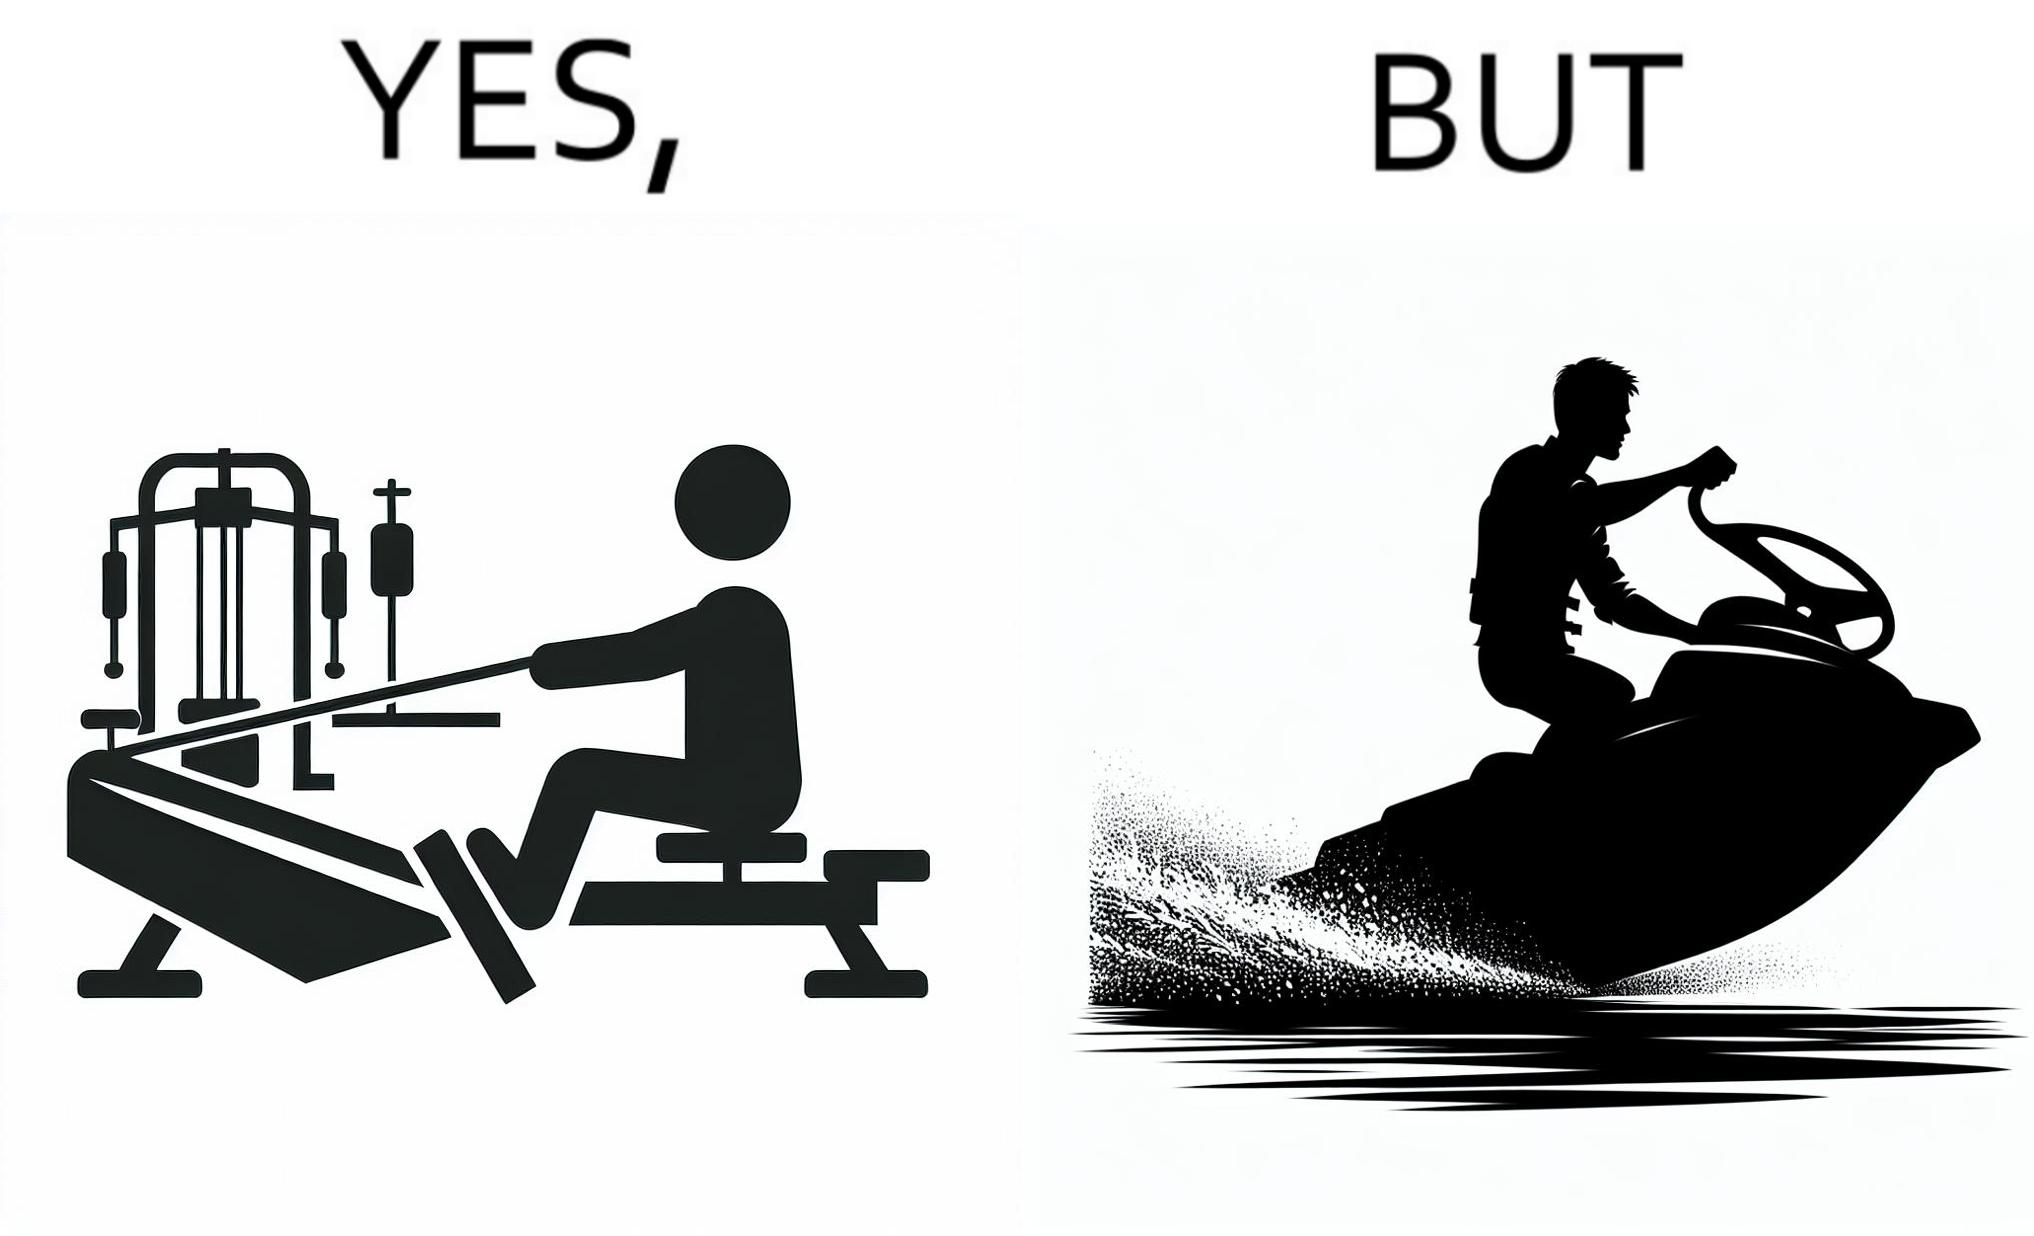What does this image depict? The image is ironic, because people often use rowing machine at the gym don't prefer rowing when it comes to boats 